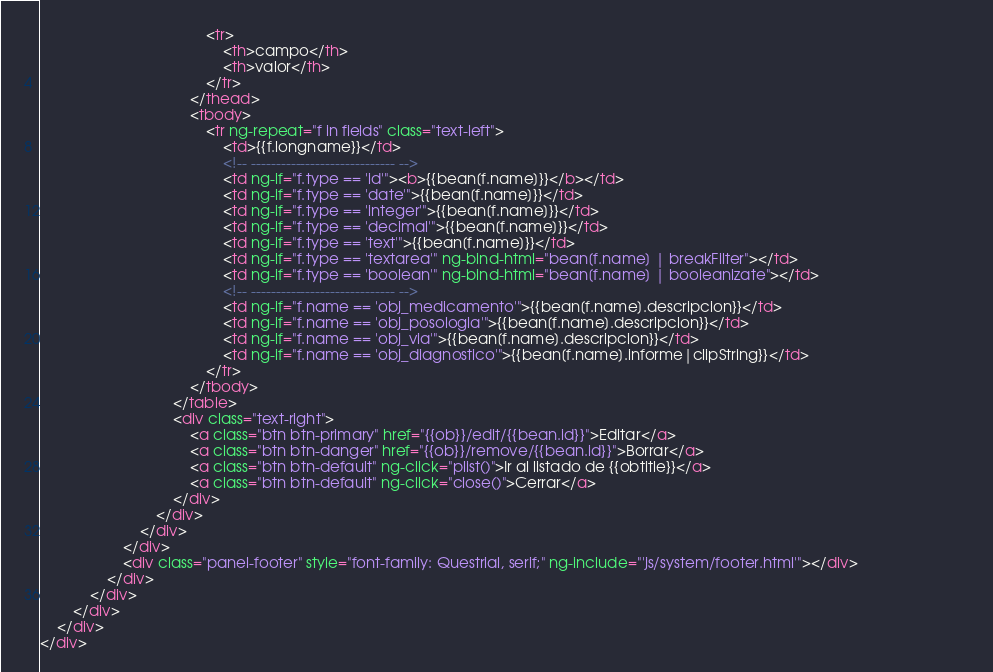Convert code to text. <code><loc_0><loc_0><loc_500><loc_500><_HTML_>                                        <tr>
                                            <th>campo</th>
                                            <th>valor</th>
                                        </tr>
                                    </thead>
                                    <tbody>
                                        <tr ng-repeat="f in fields" class="text-left">
                                            <td>{{f.longname}}</td>
                                            <!-- ----------------------------- -->
                                            <td ng-if="f.type == 'id'"><b>{{bean[f.name]}}</b></td>
                                            <td ng-if="f.type == 'date'">{{bean[f.name]}}</td>
                                            <td ng-if="f.type == 'integer'">{{bean[f.name]}}</td>
                                            <td ng-if="f.type == 'decimal'">{{bean[f.name]}}</td>
                                            <td ng-if="f.type == 'text'">{{bean[f.name]}}</td>
                                            <td ng-if="f.type == 'textarea'" ng-bind-html="bean[f.name] | breakFilter"></td>
                                            <td ng-if="f.type == 'boolean'" ng-bind-html="bean[f.name] | booleanizate"></td>
                                            <!-- ----------------------------- -->                                            
                                            <td ng-if="f.name == 'obj_medicamento'">{{bean[f.name].descripcion}}</td>                                             
                                            <td ng-if="f.name == 'obj_posologia'">{{bean[f.name].descripcion}}</td> 
                                            <td ng-if="f.name == 'obj_via'">{{bean[f.name].descripcion}}</td>                                              
                                            <td ng-if="f.name == 'obj_diagnostico'">{{bean[f.name].informe|clipString}}</td> 
                                        </tr>
                                    </tbody>
                                </table>
                                <div class="text-right">
                                    <a class="btn btn-primary" href="{{ob}}/edit/{{bean.id}}">Editar</a>
                                    <a class="btn btn-danger" href="{{ob}}/remove/{{bean.id}}">Borrar</a>
                                    <a class="btn btn-default" ng-click="plist()">Ir al listado de {{obtitle}}</a>
                                    <a class="btn btn-default" ng-click="close()">Cerrar</a>
                                </div>
                            </div>
                        </div>
                    </div>
                    <div class="panel-footer" style="font-family: Questrial, serif;" ng-include="'js/system/footer.html'"></div>
                </div>
            </div>
        </div>
    </div>
</div></code> 